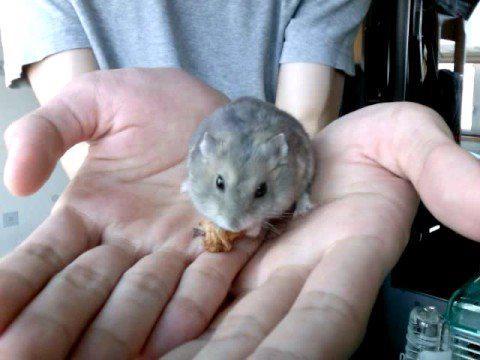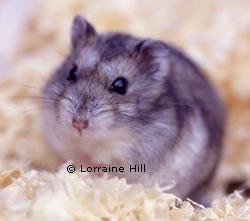The first image is the image on the left, the second image is the image on the right. For the images displayed, is the sentence "Each image contains a single pet rodent, and one of the rodents is held in a pair of upturned hands." factually correct? Answer yes or no. Yes. The first image is the image on the left, the second image is the image on the right. Examine the images to the left and right. Is the description "The right image contains a human touching a rodent." accurate? Answer yes or no. No. 